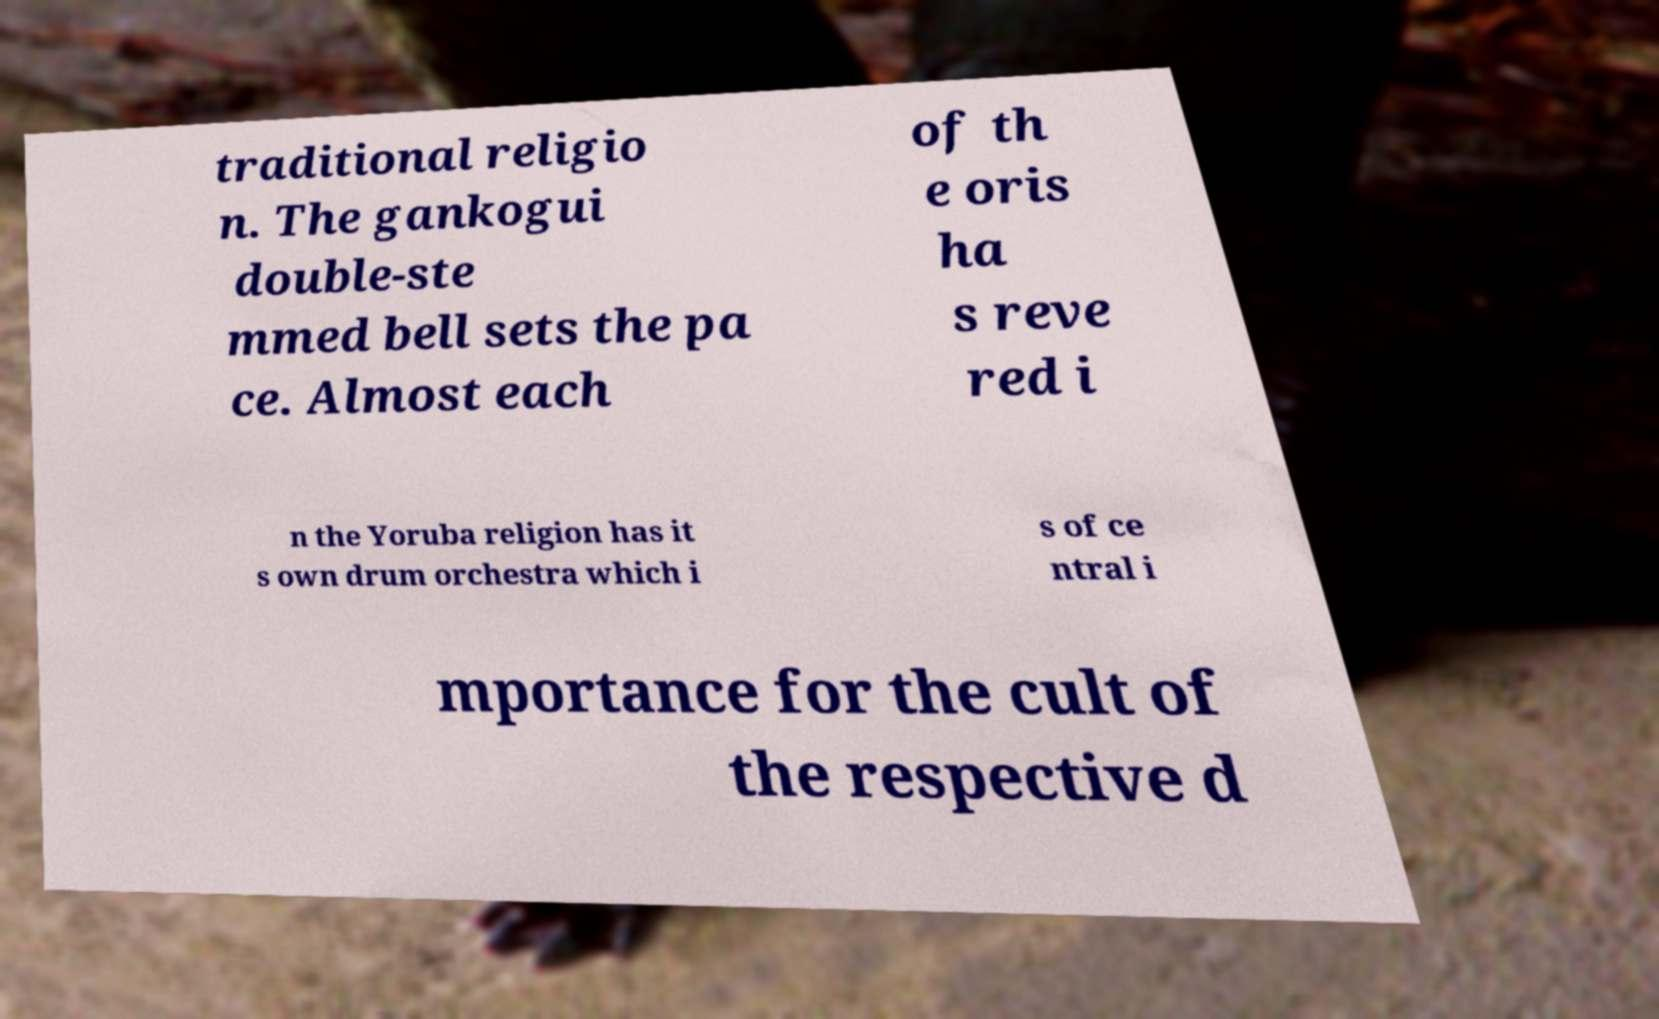Please read and relay the text visible in this image. What does it say? traditional religio n. The gankogui double-ste mmed bell sets the pa ce. Almost each of th e oris ha s reve red i n the Yoruba religion has it s own drum orchestra which i s of ce ntral i mportance for the cult of the respective d 